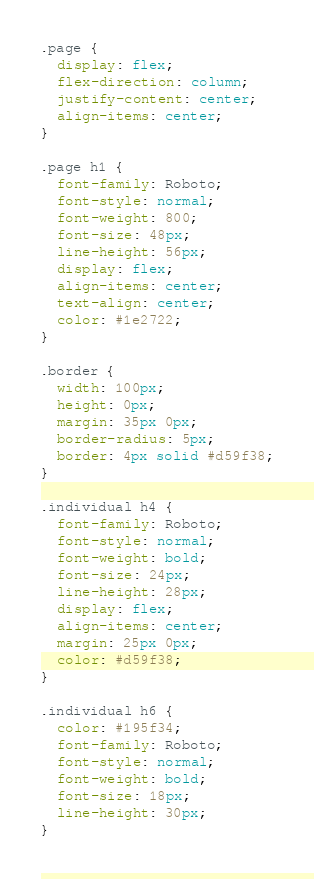Convert code to text. <code><loc_0><loc_0><loc_500><loc_500><_CSS_>.page {
  display: flex;
  flex-direction: column;
  justify-content: center;
  align-items: center;
}

.page h1 {
  font-family: Roboto;
  font-style: normal;
  font-weight: 800;
  font-size: 48px;
  line-height: 56px;
  display: flex;
  align-items: center;
  text-align: center;
  color: #1e2722;
}

.border {
  width: 100px;
  height: 0px;
  margin: 35px 0px;
  border-radius: 5px;
  border: 4px solid #d59f38;
}

.individual h4 {
  font-family: Roboto;
  font-style: normal;
  font-weight: bold;
  font-size: 24px;
  line-height: 28px;
  display: flex;
  align-items: center;
  margin: 25px 0px;
  color: #d59f38;
}

.individual h6 {
  color: #195f34;
  font-family: Roboto;
  font-style: normal;
  font-weight: bold;
  font-size: 18px;
  line-height: 30px;
}
</code> 